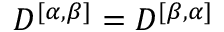Convert formula to latex. <formula><loc_0><loc_0><loc_500><loc_500>D ^ { [ \alpha , \beta ] } = D ^ { [ \beta , \alpha ] }</formula> 